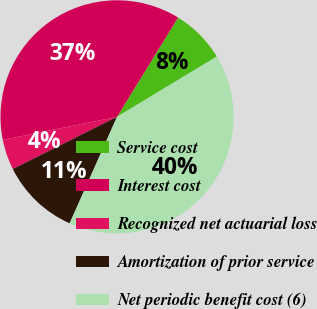<chart> <loc_0><loc_0><loc_500><loc_500><pie_chart><fcel>Service cost<fcel>Interest cost<fcel>Recognized net actuarial loss<fcel>Amortization of prior service<fcel>Net periodic benefit cost (6)<nl><fcel>7.58%<fcel>36.94%<fcel>4.21%<fcel>10.95%<fcel>40.31%<nl></chart> 